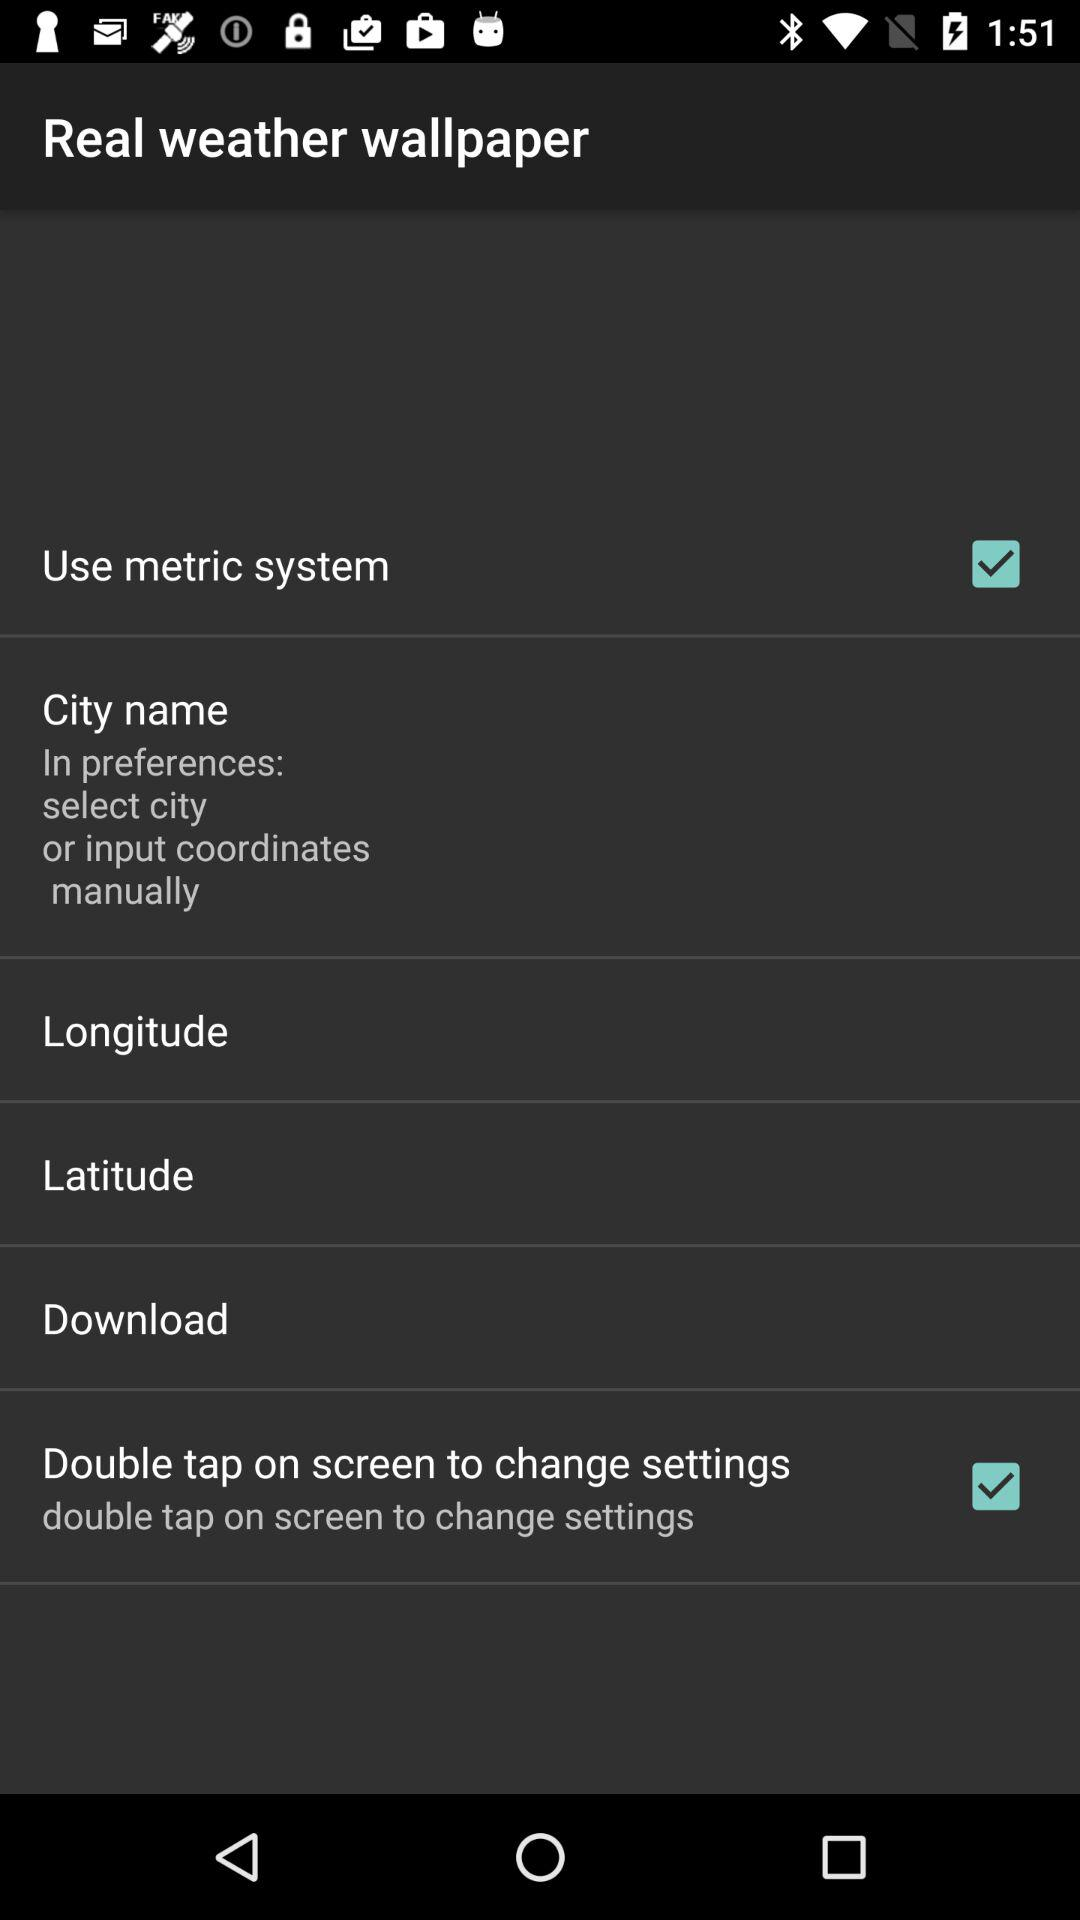What is the status of "Use metric system"? The status of "Use metric system" is "on". 